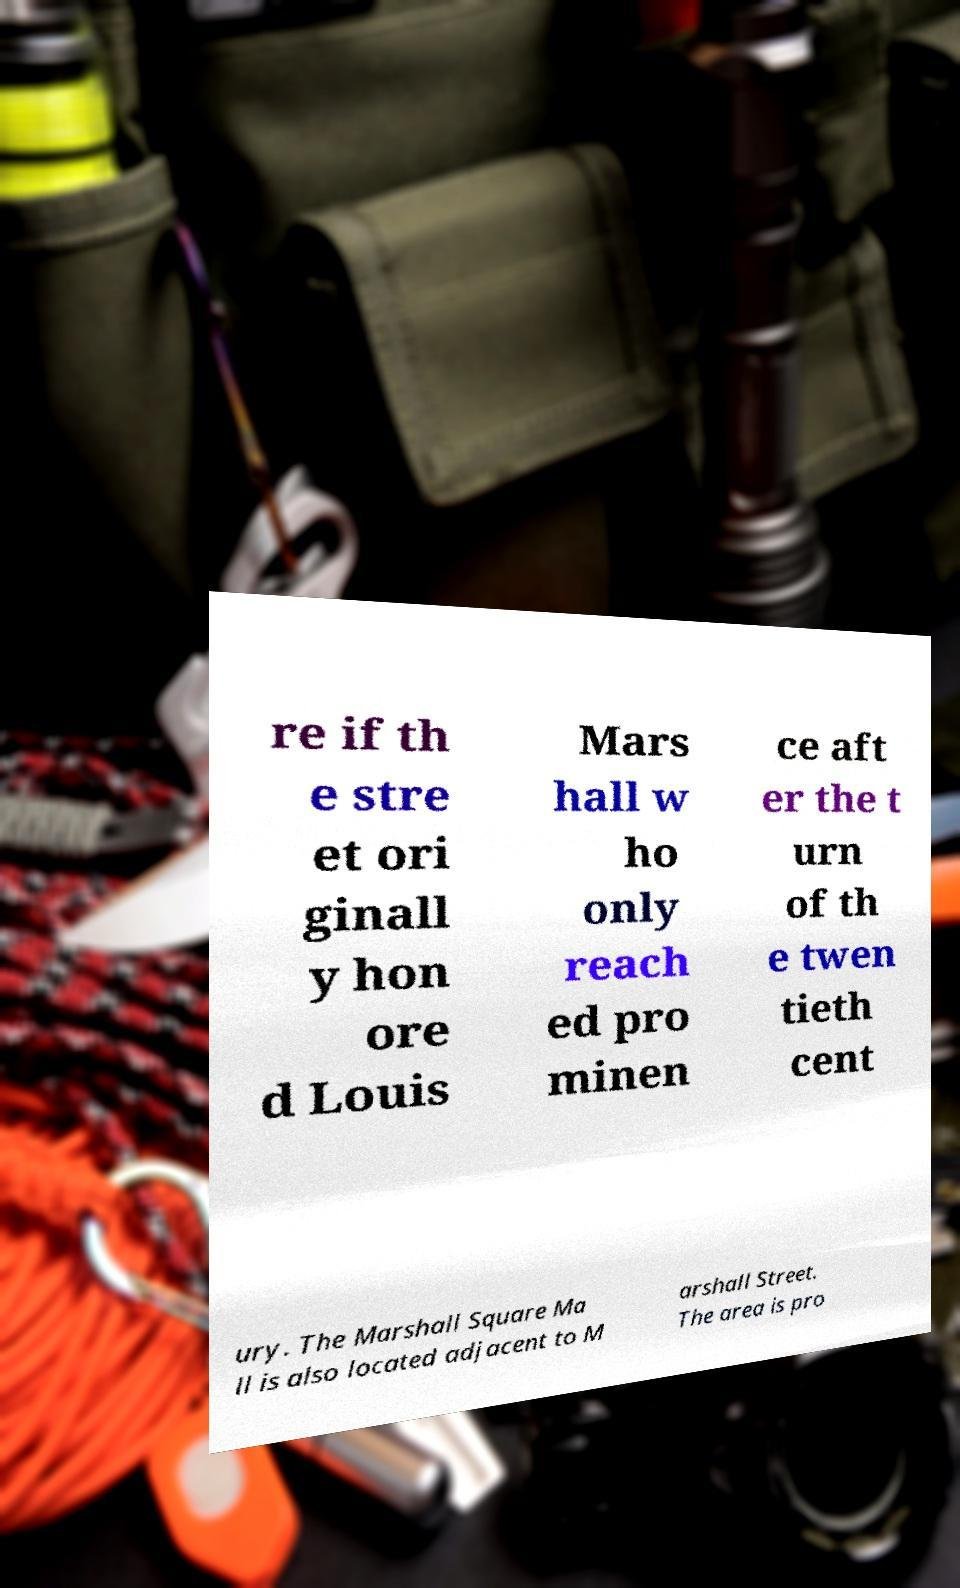There's text embedded in this image that I need extracted. Can you transcribe it verbatim? re if th e stre et ori ginall y hon ore d Louis Mars hall w ho only reach ed pro minen ce aft er the t urn of th e twen tieth cent ury. The Marshall Square Ma ll is also located adjacent to M arshall Street. The area is pro 